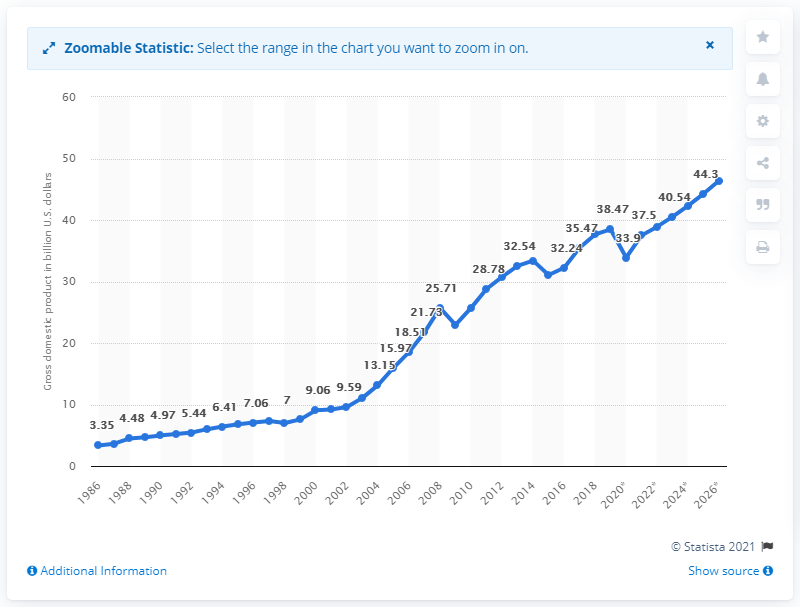Specify some key components in this picture. In 2019, Bahrain's gross domestic product (GDP) was approximately 38.47 billion dollars. 